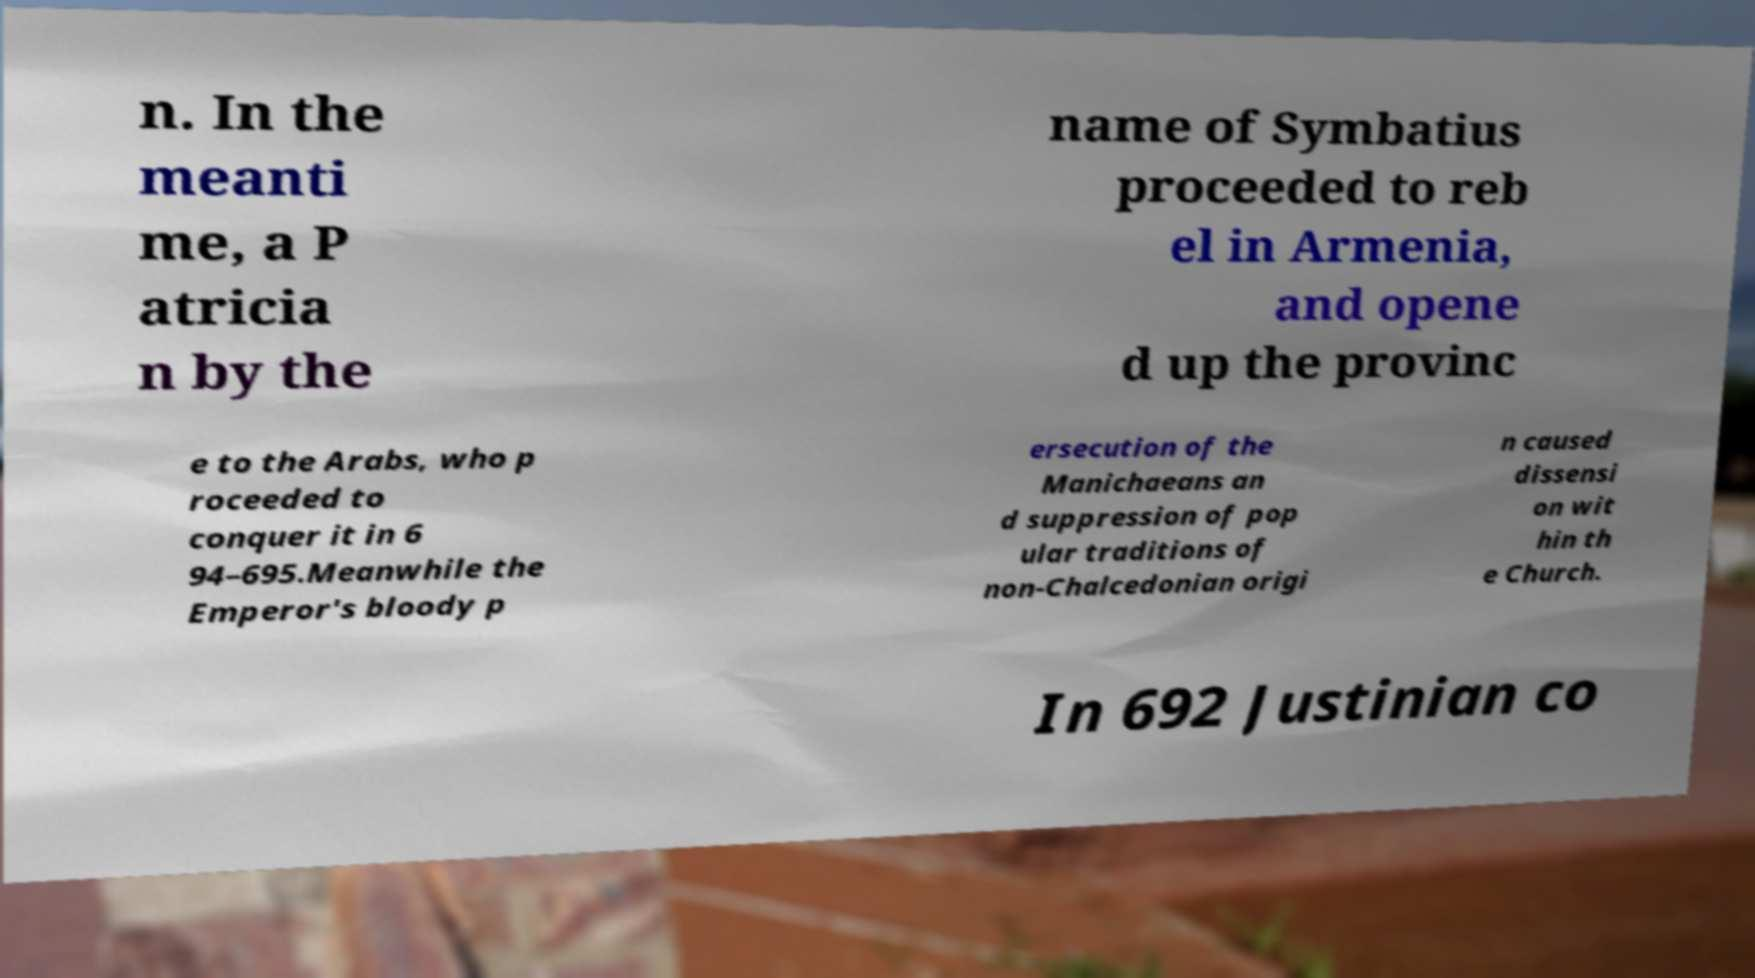Please read and relay the text visible in this image. What does it say? n. In the meanti me, a P atricia n by the name of Symbatius proceeded to reb el in Armenia, and opene d up the provinc e to the Arabs, who p roceeded to conquer it in 6 94–695.Meanwhile the Emperor's bloody p ersecution of the Manichaeans an d suppression of pop ular traditions of non-Chalcedonian origi n caused dissensi on wit hin th e Church. In 692 Justinian co 